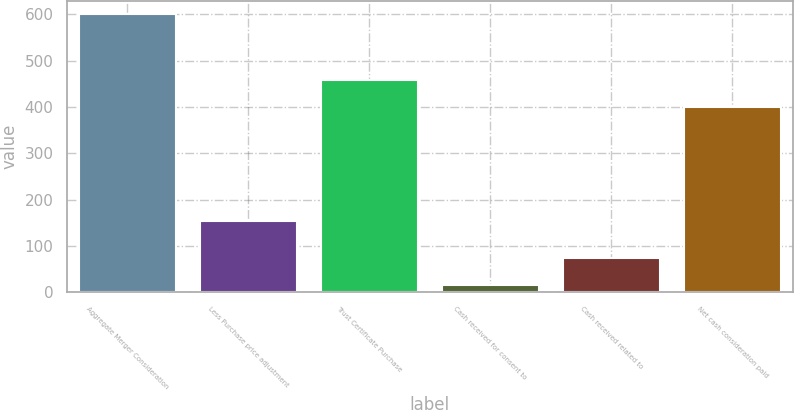<chart> <loc_0><loc_0><loc_500><loc_500><bar_chart><fcel>Aggregate Merger Consideration<fcel>Less Purchase price adjustment<fcel>Trust Certificate Purchase<fcel>Cash received for consent to<fcel>Cash received related to<fcel>Net cash consideration paid<nl><fcel>600<fcel>154<fcel>459.4<fcel>16<fcel>74.4<fcel>401<nl></chart> 